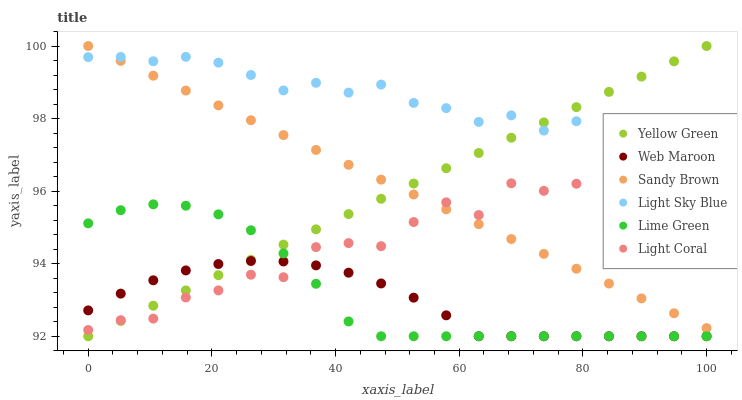Does Web Maroon have the minimum area under the curve?
Answer yes or no. Yes. Does Light Sky Blue have the maximum area under the curve?
Answer yes or no. Yes. Does Lime Green have the minimum area under the curve?
Answer yes or no. No. Does Lime Green have the maximum area under the curve?
Answer yes or no. No. Is Yellow Green the smoothest?
Answer yes or no. Yes. Is Light Coral the roughest?
Answer yes or no. Yes. Is Lime Green the smoothest?
Answer yes or no. No. Is Lime Green the roughest?
Answer yes or no. No. Does Yellow Green have the lowest value?
Answer yes or no. Yes. Does Light Coral have the lowest value?
Answer yes or no. No. Does Sandy Brown have the highest value?
Answer yes or no. Yes. Does Lime Green have the highest value?
Answer yes or no. No. Is Lime Green less than Light Sky Blue?
Answer yes or no. Yes. Is Sandy Brown greater than Web Maroon?
Answer yes or no. Yes. Does Light Coral intersect Sandy Brown?
Answer yes or no. Yes. Is Light Coral less than Sandy Brown?
Answer yes or no. No. Is Light Coral greater than Sandy Brown?
Answer yes or no. No. Does Lime Green intersect Light Sky Blue?
Answer yes or no. No. 